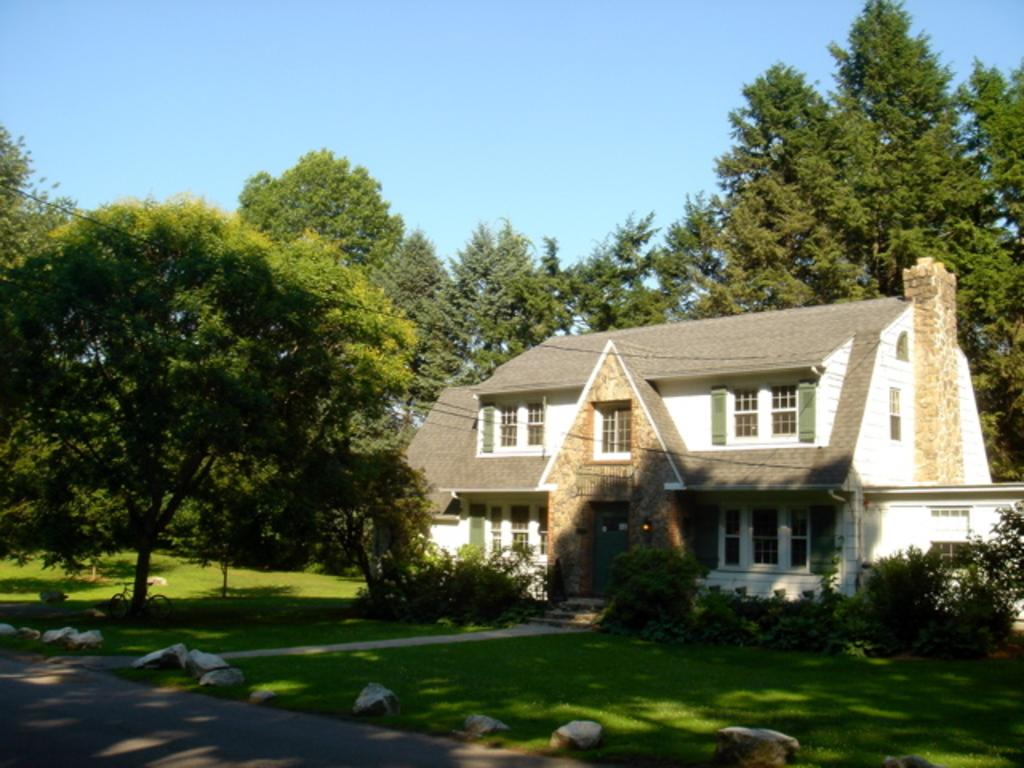What type of structure is present in the image? There is a building in the image. What natural elements can be seen in the image? There are trees in the image. What mode of transportation is visible in the image? There is a bicycle in the image. What type of ground surface is present in the image? There are stones in the image. What can be seen in the background of the image? The sky is visible in the background of the image. Where is the sofa located in the image? There is no sofa present in the image. What type of bun is being used as a decoration in the image? There is no bun present in the image. 